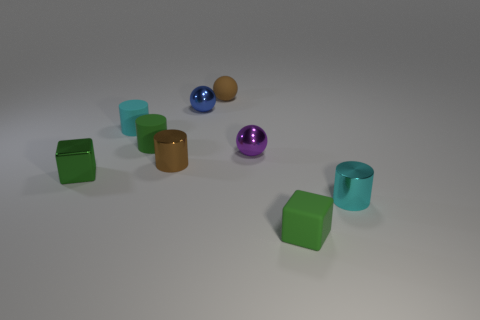How many green cubes must be subtracted to get 1 green cubes? 1 Subtract all brown blocks. How many cyan cylinders are left? 2 Subtract all brown cylinders. How many cylinders are left? 3 Subtract all tiny brown cylinders. How many cylinders are left? 3 Subtract all gray cylinders. Subtract all yellow spheres. How many cylinders are left? 4 Subtract 0 red blocks. How many objects are left? 9 Subtract all cubes. How many objects are left? 7 Subtract all big purple matte objects. Subtract all metal cubes. How many objects are left? 8 Add 7 small green rubber cylinders. How many small green rubber cylinders are left? 8 Add 8 purple balls. How many purple balls exist? 9 